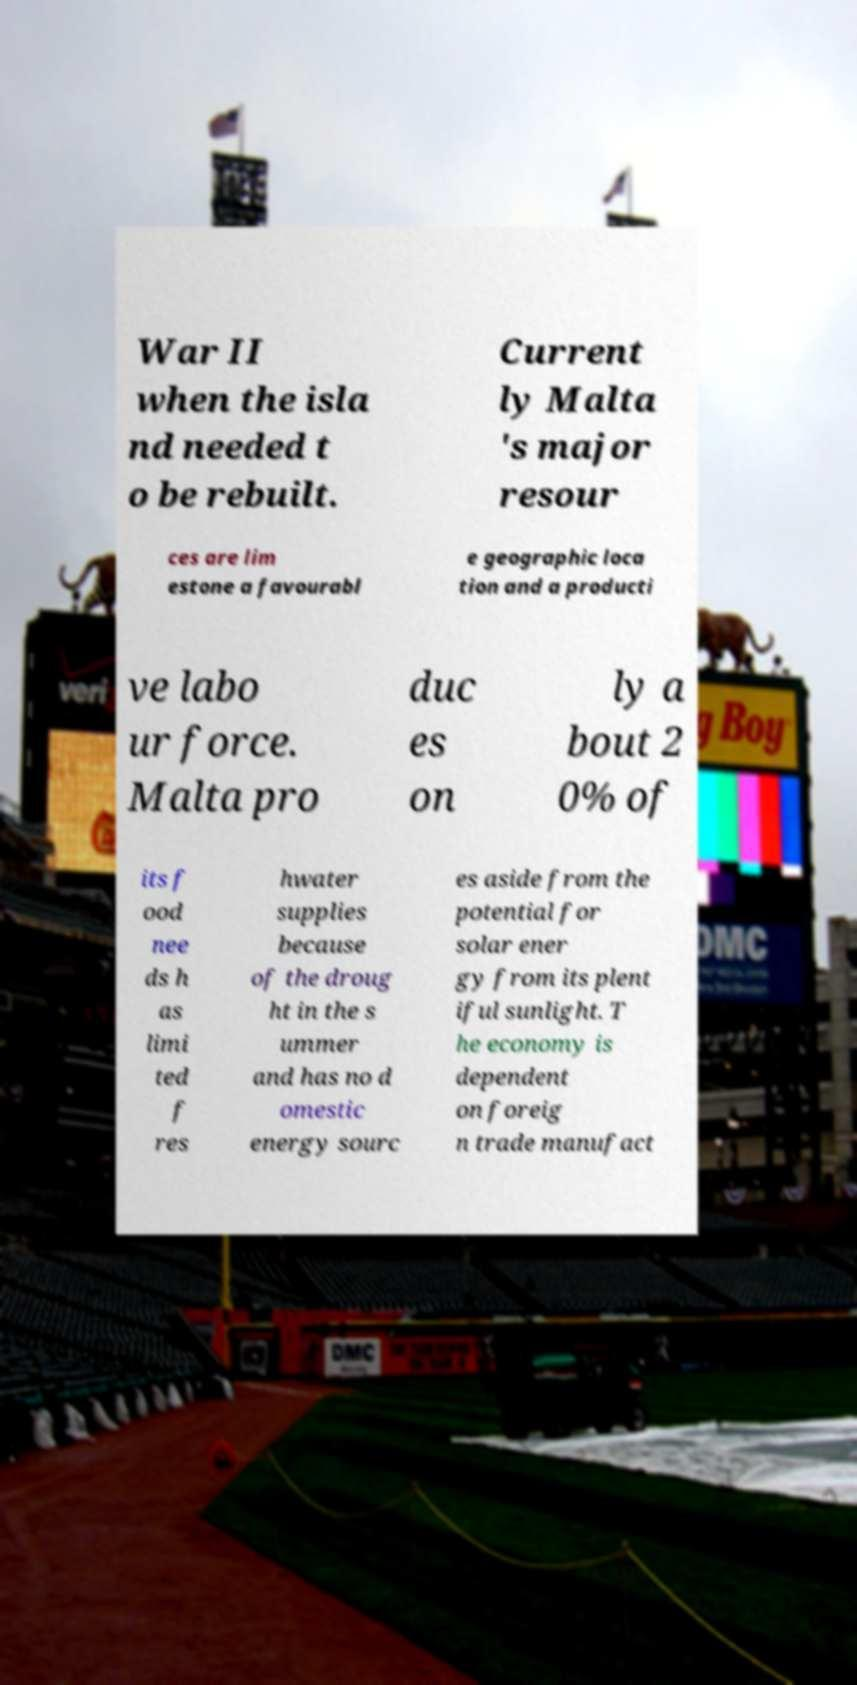I need the written content from this picture converted into text. Can you do that? War II when the isla nd needed t o be rebuilt. Current ly Malta 's major resour ces are lim estone a favourabl e geographic loca tion and a producti ve labo ur force. Malta pro duc es on ly a bout 2 0% of its f ood nee ds h as limi ted f res hwater supplies because of the droug ht in the s ummer and has no d omestic energy sourc es aside from the potential for solar ener gy from its plent iful sunlight. T he economy is dependent on foreig n trade manufact 